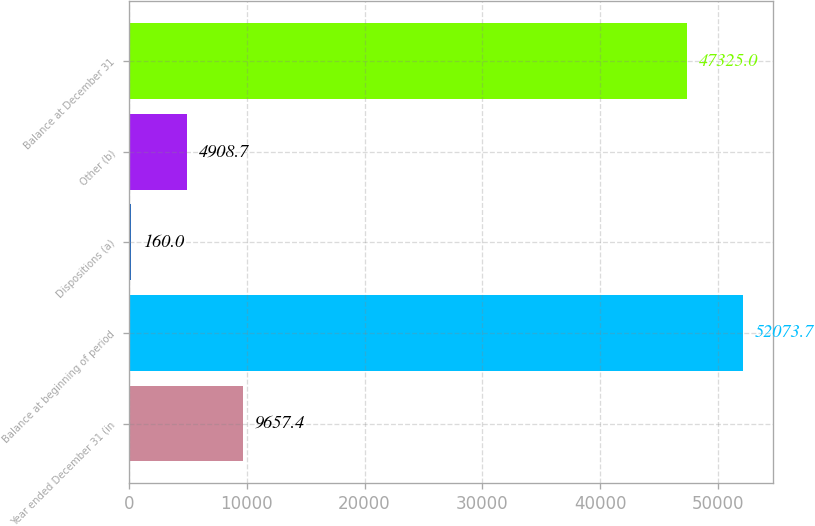<chart> <loc_0><loc_0><loc_500><loc_500><bar_chart><fcel>Year ended December 31 (in<fcel>Balance at beginning of period<fcel>Dispositions (a)<fcel>Other (b)<fcel>Balance at December 31<nl><fcel>9657.4<fcel>52073.7<fcel>160<fcel>4908.7<fcel>47325<nl></chart> 